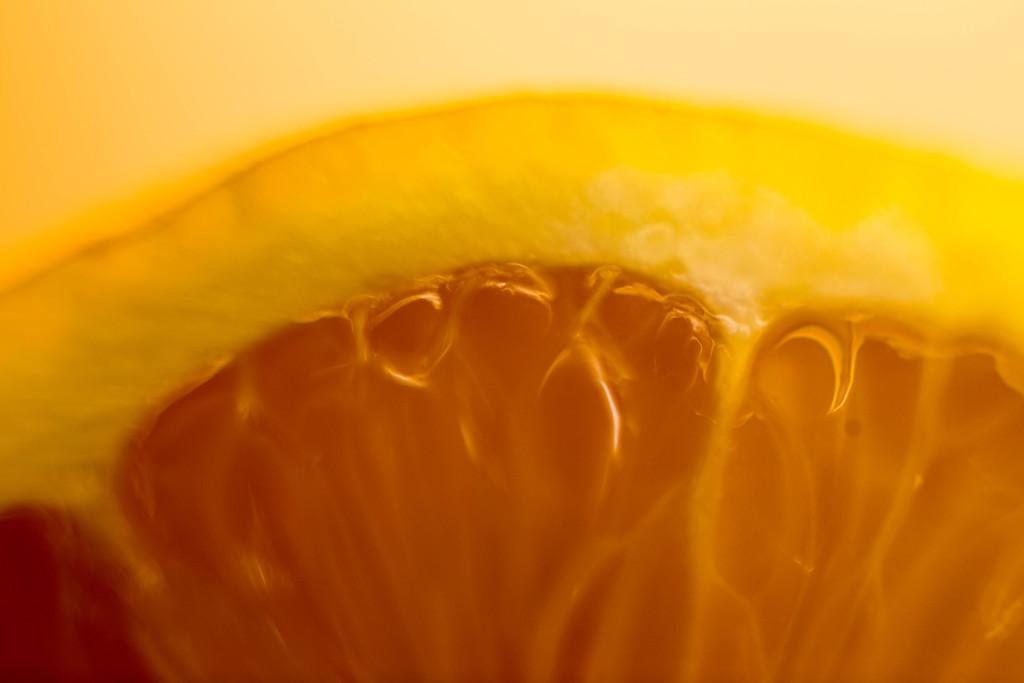What colors are present in the object that can be seen in the image? The object in the image has orange and yellow colors. What type of mine is visible in the image? There is no mine present in the image; the object mentioned has orange and yellow colors. 